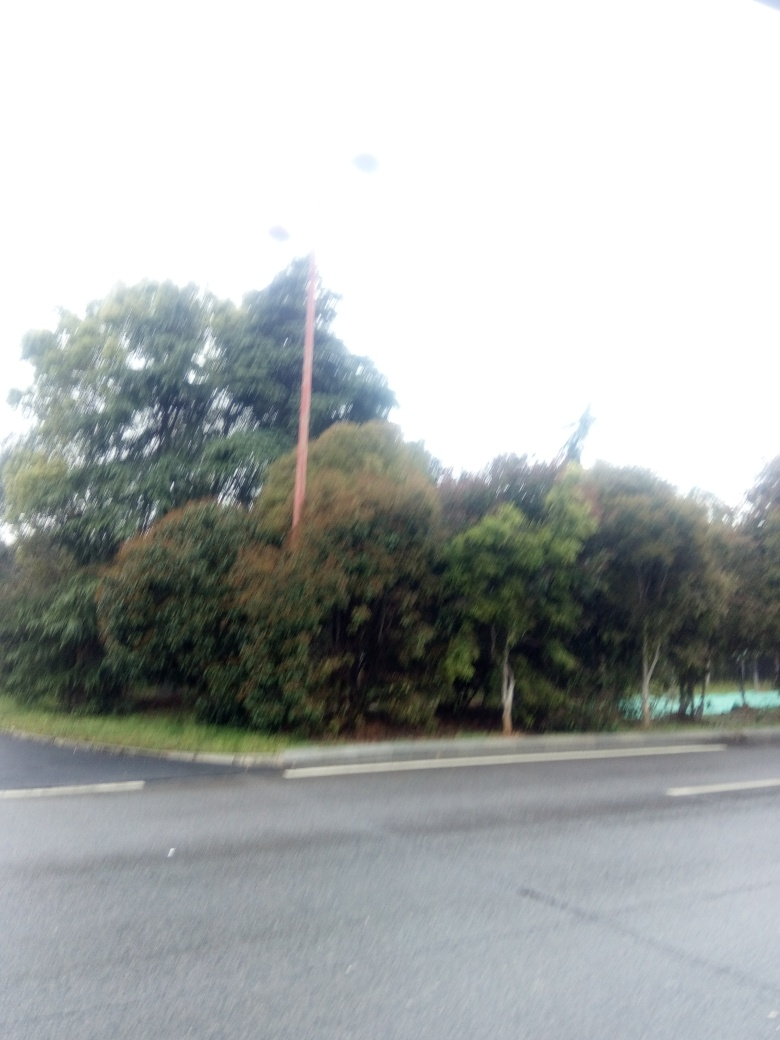Can you identify any specific objects or details despite the overexposure? Despite the challenging lighting conditions in the image, it's possible to make out the silhouettes of trees and a stretch of road, suggesting an outdoor scene perhaps captured on an overcast day. 